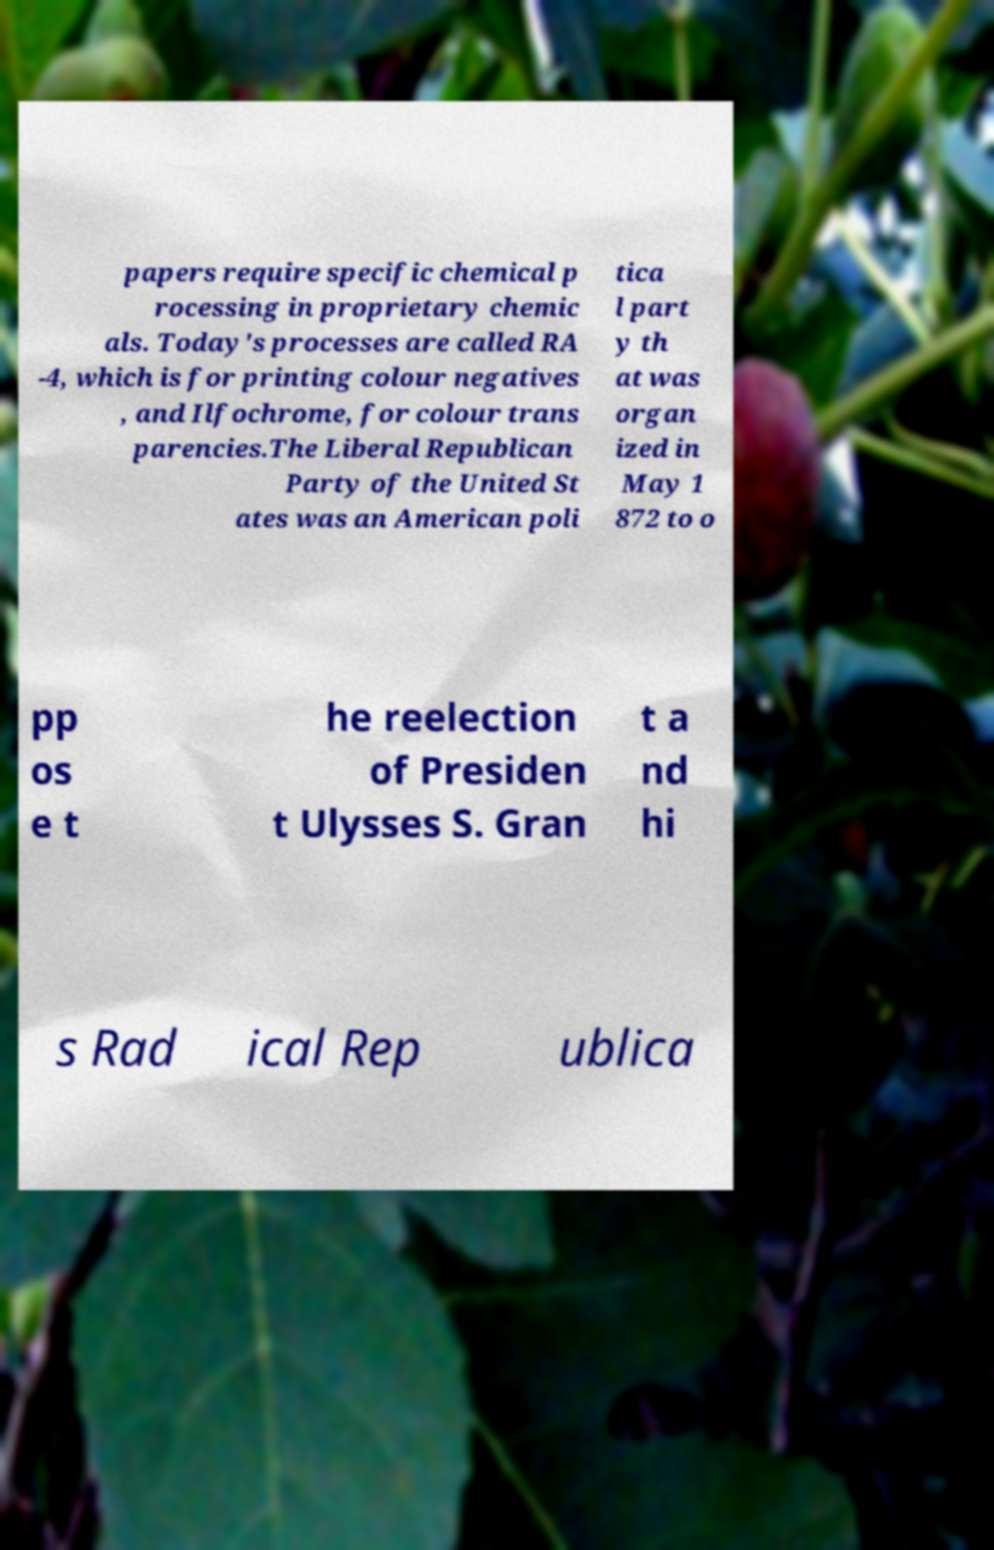Can you read and provide the text displayed in the image?This photo seems to have some interesting text. Can you extract and type it out for me? papers require specific chemical p rocessing in proprietary chemic als. Today's processes are called RA -4, which is for printing colour negatives , and Ilfochrome, for colour trans parencies.The Liberal Republican Party of the United St ates was an American poli tica l part y th at was organ ized in May 1 872 to o pp os e t he reelection of Presiden t Ulysses S. Gran t a nd hi s Rad ical Rep ublica 